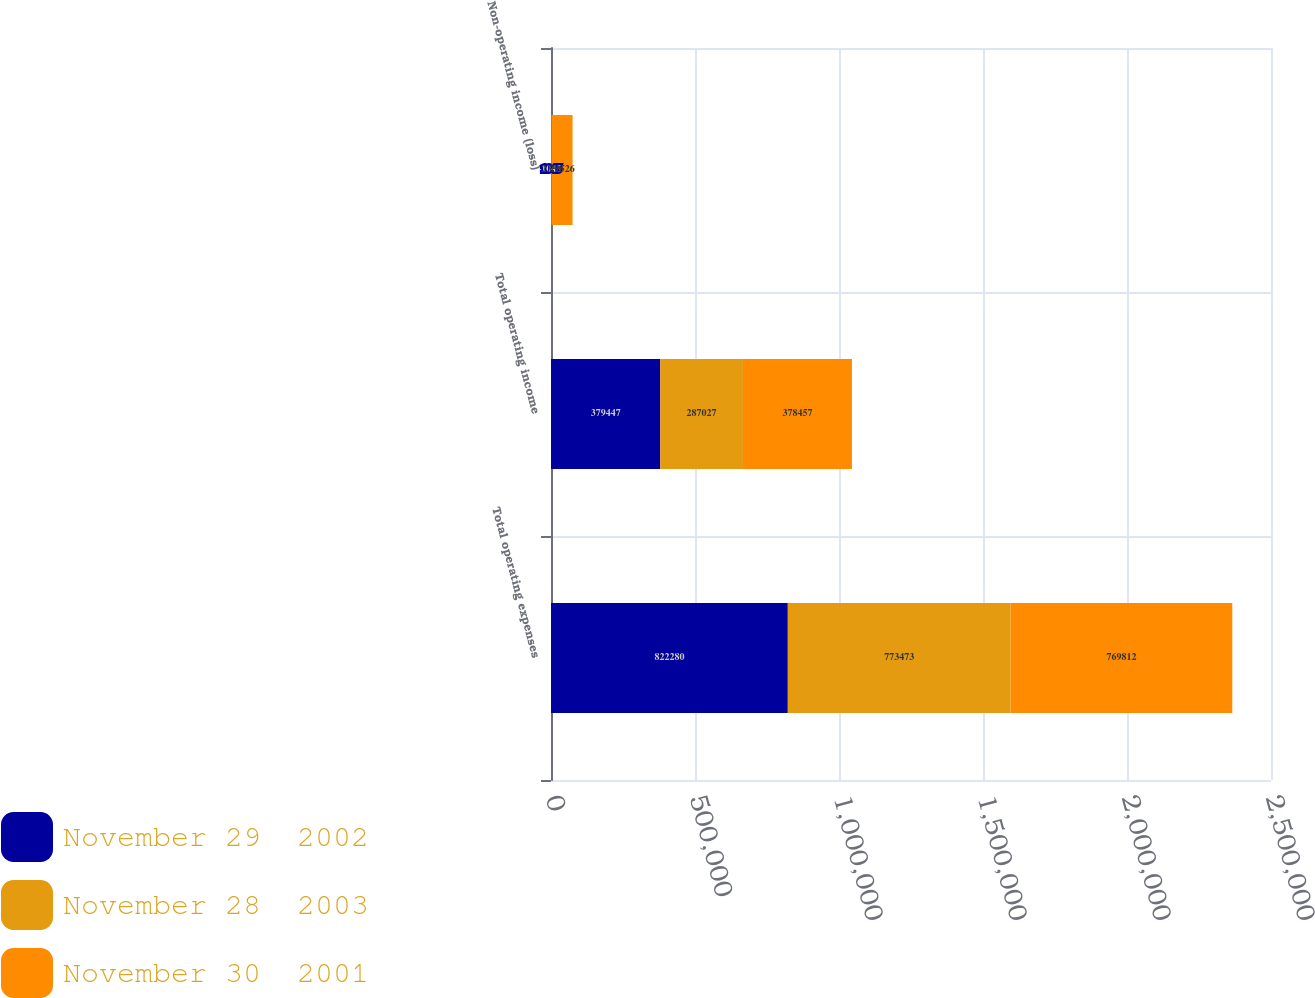Convert chart. <chart><loc_0><loc_0><loc_500><loc_500><stacked_bar_chart><ecel><fcel>Total operating expenses<fcel>Total operating income<fcel>Non-operating income (loss)<nl><fcel>November 29  2002<fcel>822280<fcel>379447<fcel>1045<nl><fcel>November 28  2003<fcel>773473<fcel>287027<fcel>2338<nl><fcel>November 30  2001<fcel>769812<fcel>378457<fcel>71526<nl></chart> 